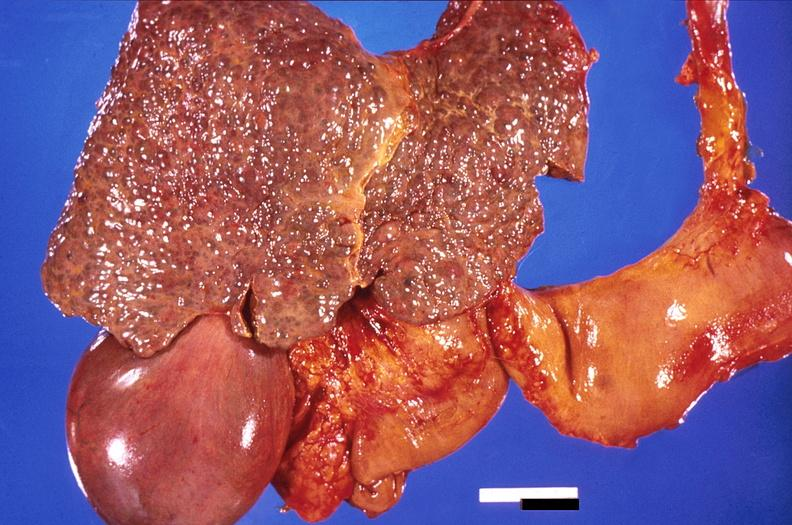s hepatobiliary present?
Answer the question using a single word or phrase. Yes 